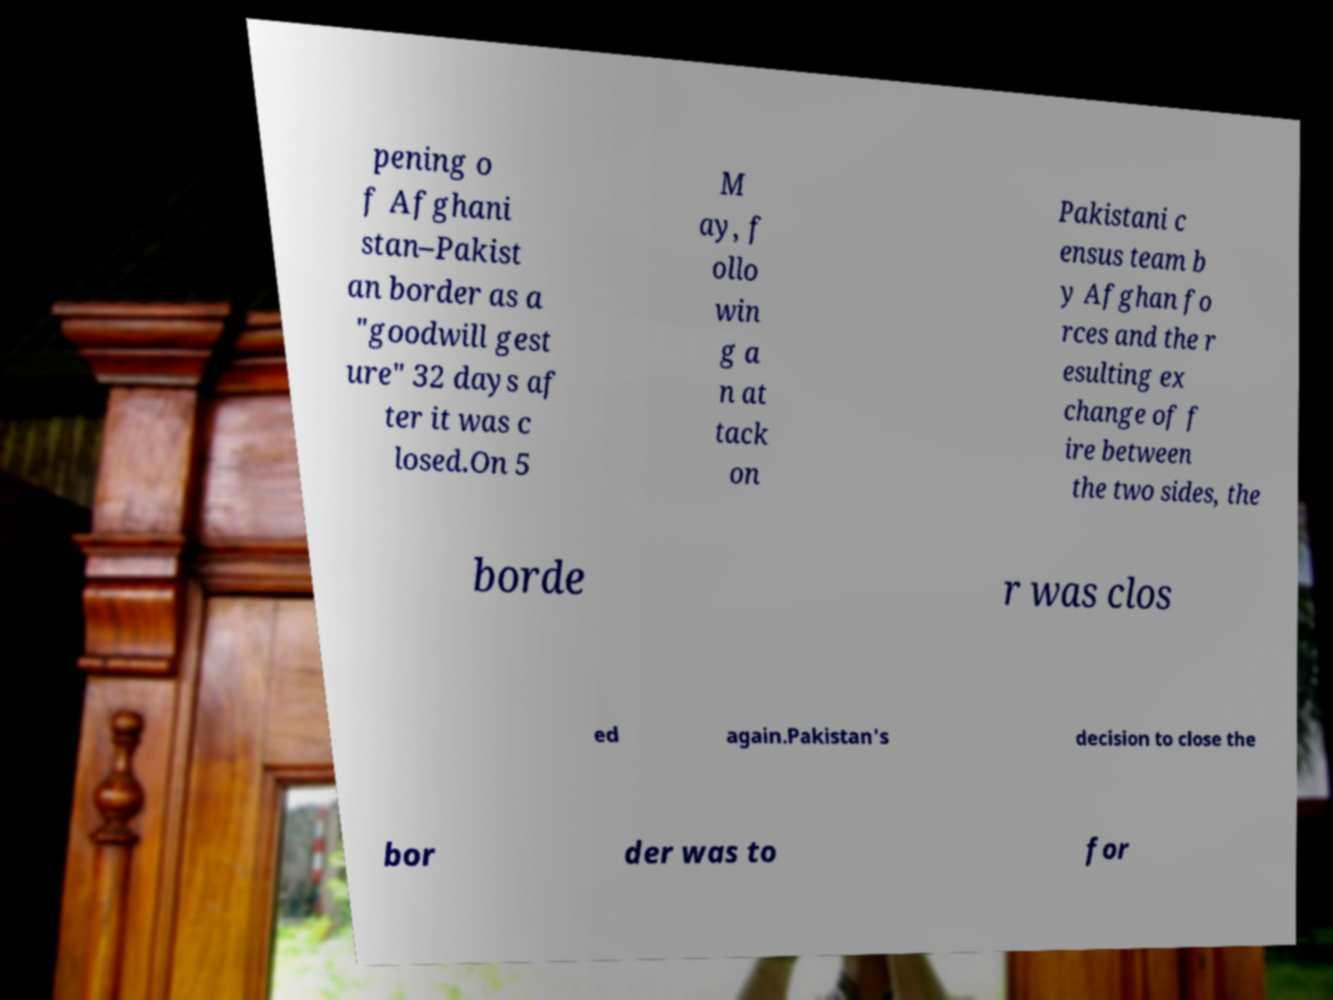Can you accurately transcribe the text from the provided image for me? pening o f Afghani stan–Pakist an border as a "goodwill gest ure" 32 days af ter it was c losed.On 5 M ay, f ollo win g a n at tack on Pakistani c ensus team b y Afghan fo rces and the r esulting ex change of f ire between the two sides, the borde r was clos ed again.Pakistan's decision to close the bor der was to for 